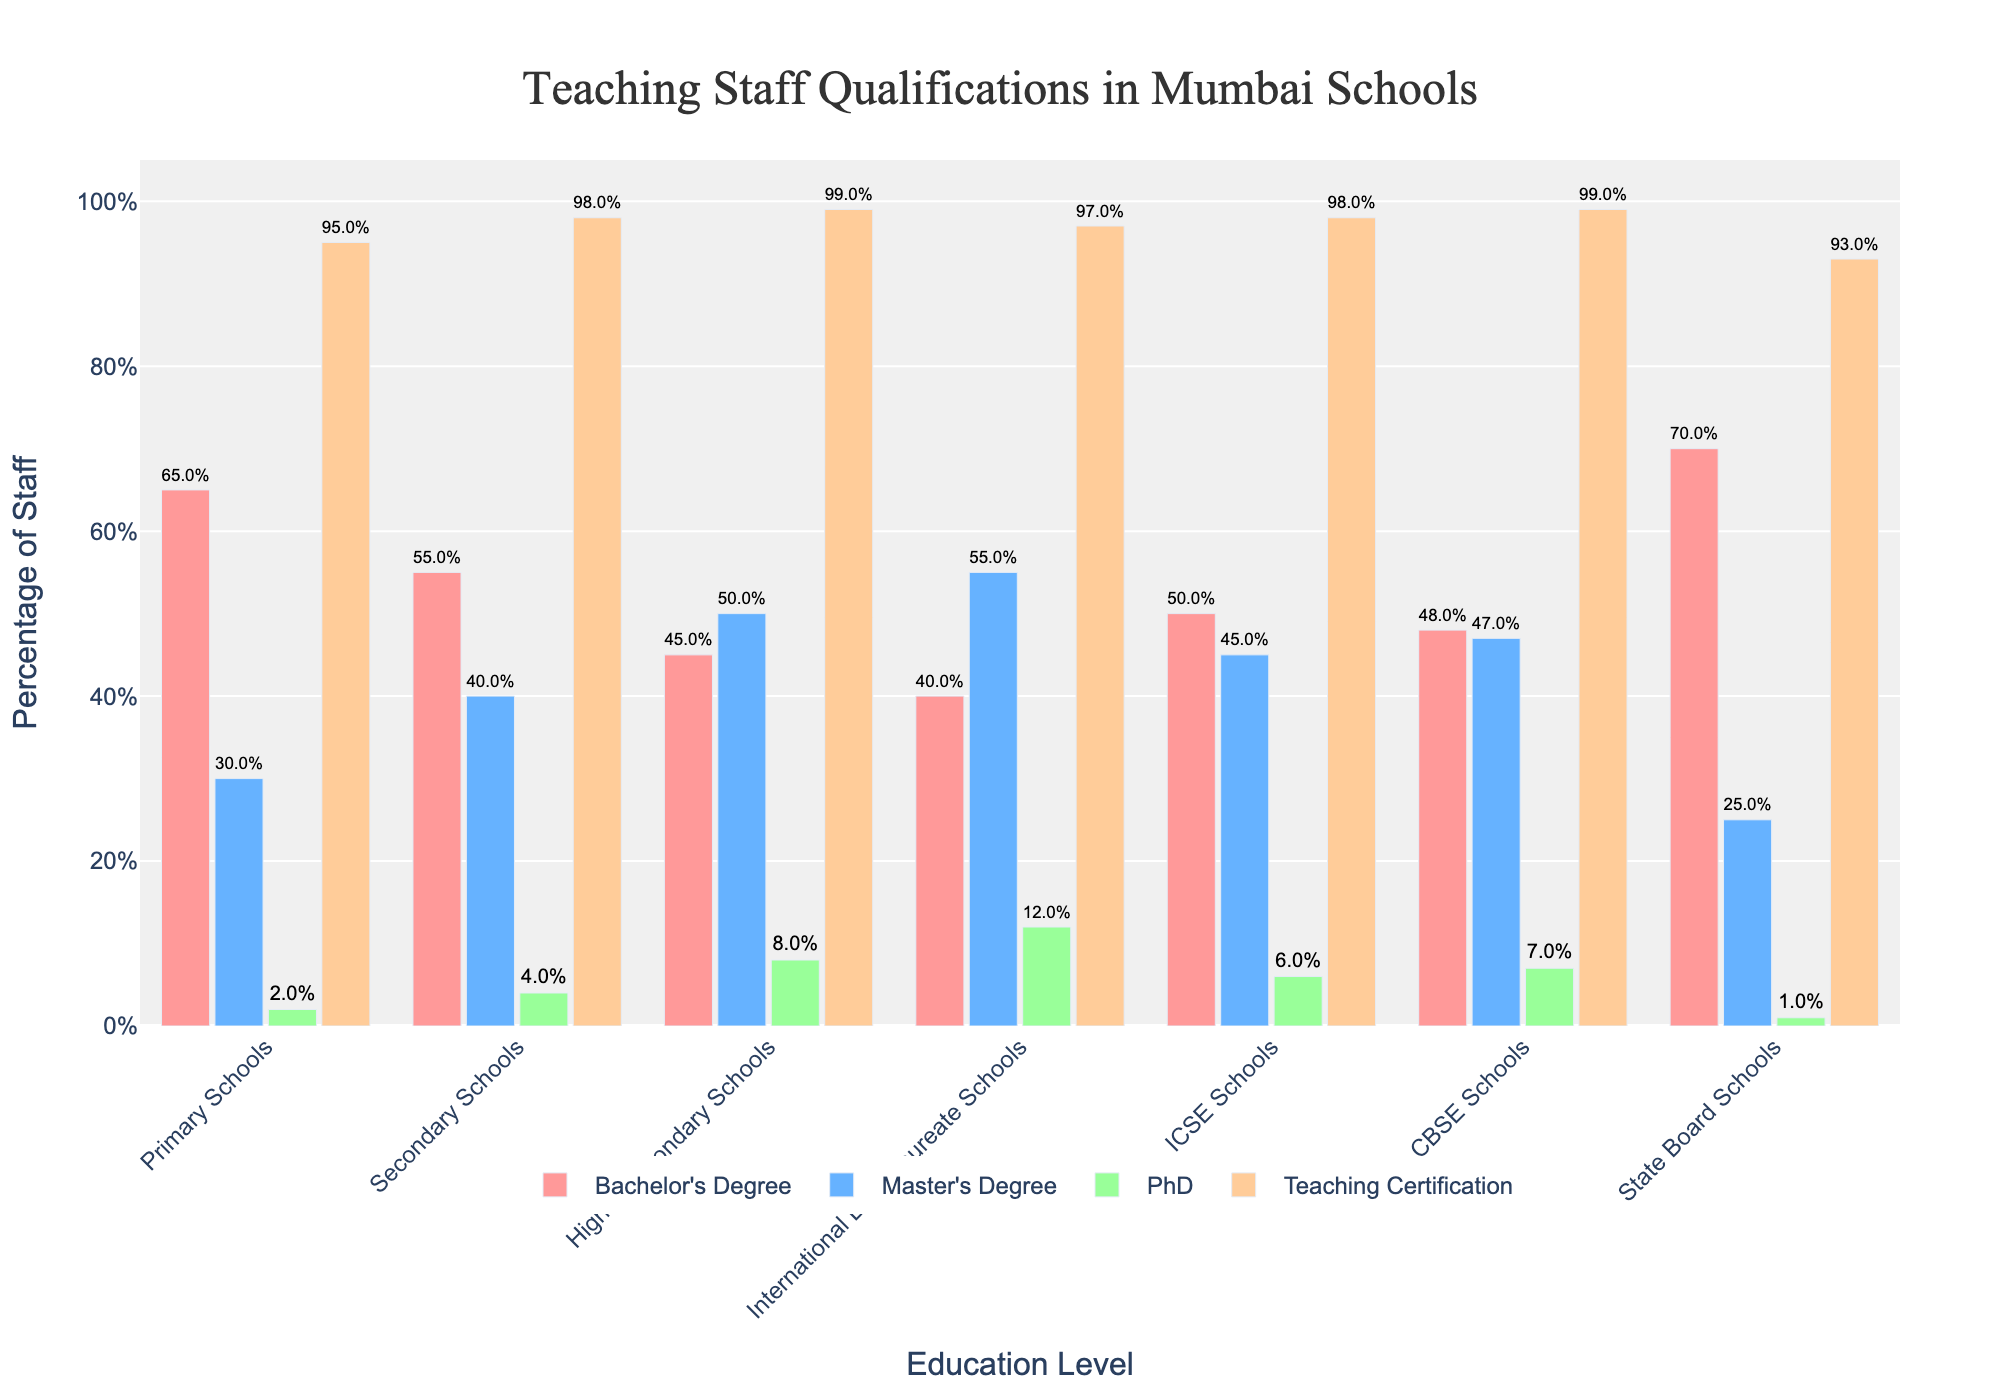Which school type has the highest percentage of staff with a Master's Degree? To find out, compare the percentage of staff with a Master's Degree for each school type. International Baccalaureate Schools have the highest with 55%.
Answer: International Baccalaureate Schools Which education level has the lowest percentage of staff with a PhD? Look at the PhD percentages for all education levels, and find the smallest value. State Board Schools have the lowest with 1%.
Answer: State Board Schools In which type of school do the majority of staff have a Bachelor's Degree? Determine this by finding the school type where the Bachelor's Degree percentage is above 50%. Primary Schools (65%) and State Board Schools (70%) fit this criterion.
Answer: Primary Schools, State Board Schools What's the difference between the percentage of staff with a Teaching Certification in Primary Schools and Secondary Schools? Subtract the percentage in Secondary Schools (98%) from the percentage in Primary Schools (95%). The result is 98% - 95% = 3%.
Answer: 3% What's the average percentage of staff with a Master's Degree across all school types? Add the percentages for each school type and divide by the number of school types. (30% + 40% + 50% + 55% + 45% + 47% + 25%) / 7 = 42.29%.
Answer: 42.29% Which school type has the smallest difference between the percentage of staff with a Bachelor's Degree and staff with a Master's Degree? Calculate the differences and compare them. For CBSE Schools (48% Bachelor's, 47% Master's), the difference is 1%, which is the smallest.
Answer: CBSE Schools Which two school types have the closest percentage of staff with Teaching Certifications? Compare the values and find the smallest difference. Secondary Schools (98%) and ICSE Schools (98%) both have the same percentage.
Answer: Secondary Schools, ICSE Schools How much more likely is it for teaching staff in International Baccalaureate Schools to have a PhD compared to Primary Schools? Calculate the difference by subtracting the PhD percentage of Primary Schools (2%) from International Baccalaureate Schools (12%). The difference is 12% - 2% = 10%.
Answer: 10% 